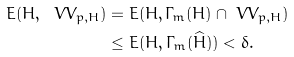Convert formula to latex. <formula><loc_0><loc_0><loc_500><loc_500>\L E ( H , \ V V _ { p , H } ) & = \L E ( H , \Gamma _ { m } ( H ) \cap \ V V _ { p , H } ) \\ & \leq \L E ( H , \Gamma _ { m } ( \widehat { H } ) ) < \delta .</formula> 